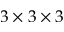<formula> <loc_0><loc_0><loc_500><loc_500>3 \times 3 \times 3</formula> 